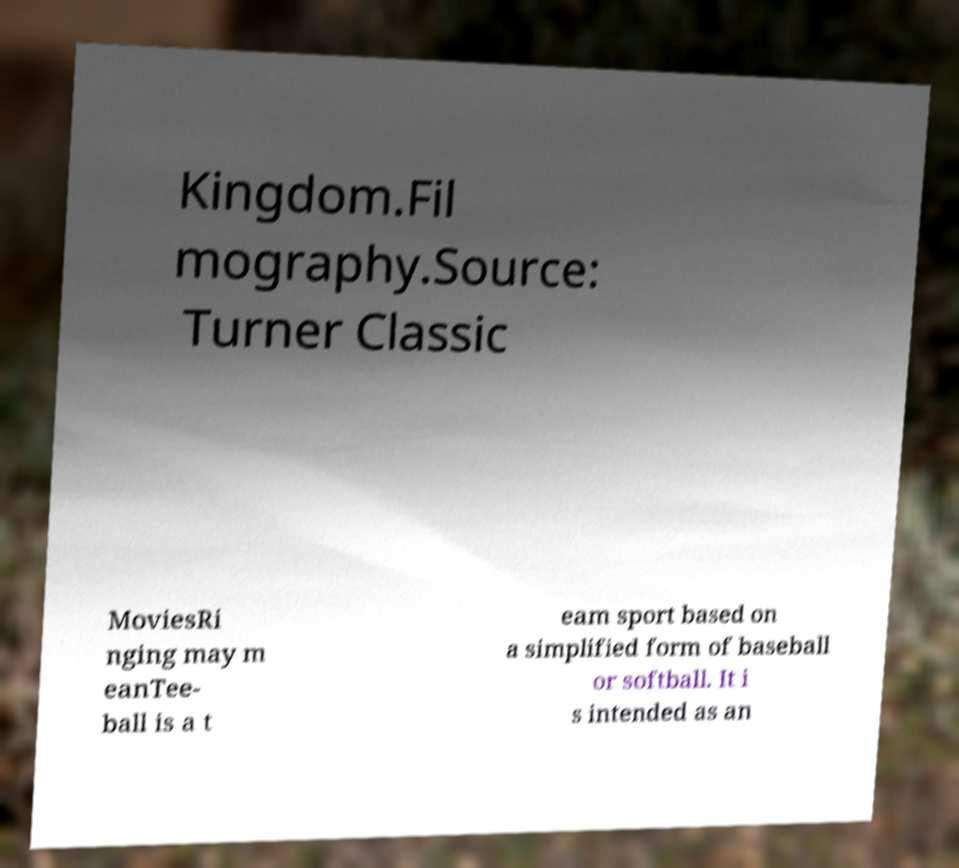Please read and relay the text visible in this image. What does it say? Kingdom.Fil mography.Source: Turner Classic MoviesRi nging may m eanTee- ball is a t eam sport based on a simplified form of baseball or softball. It i s intended as an 